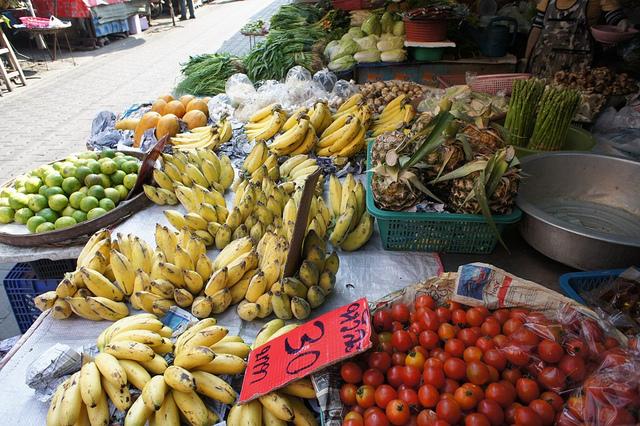Are there more bananas or oranges?
Quick response, please. Bananas. What fruit is most commonly pictured on this table?
Short answer required. Bananas. Is there anything besides bananas for sale on the tables?
Short answer required. Yes. Is there any water in the bowl?
Quick response, please. No. How many different fruits do you see?
Quick response, please. 5. How many different types of fruit are there?
Write a very short answer. 4. 